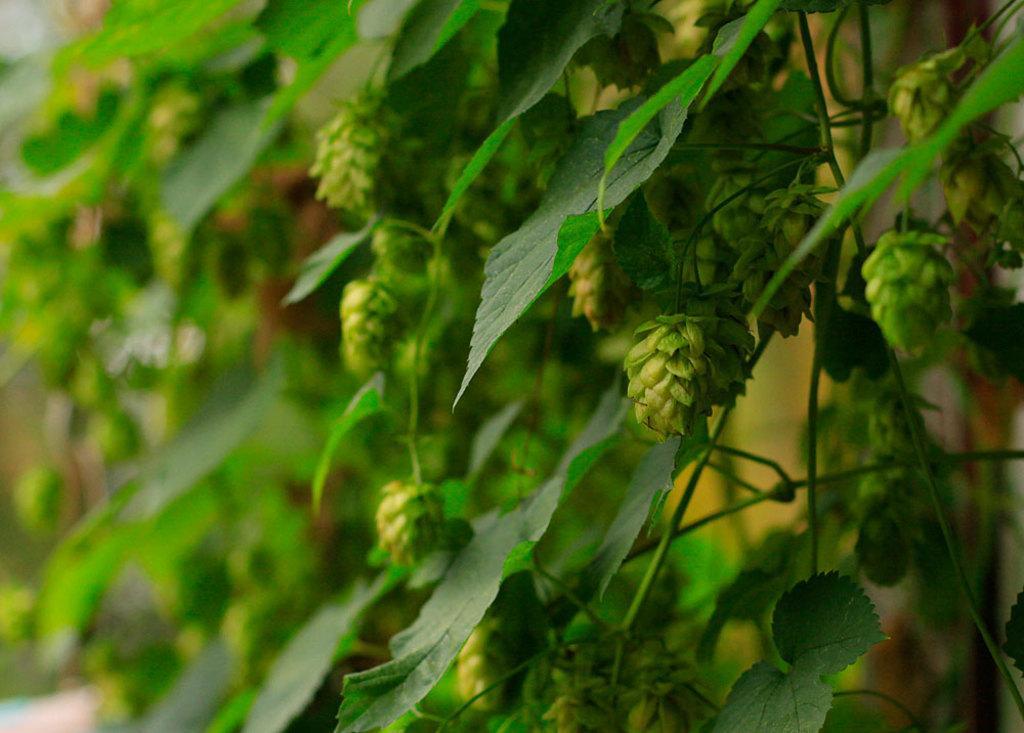Could you give a brief overview of what you see in this image? This image consists of plants along with green leaves. In the background, there is a wall. 